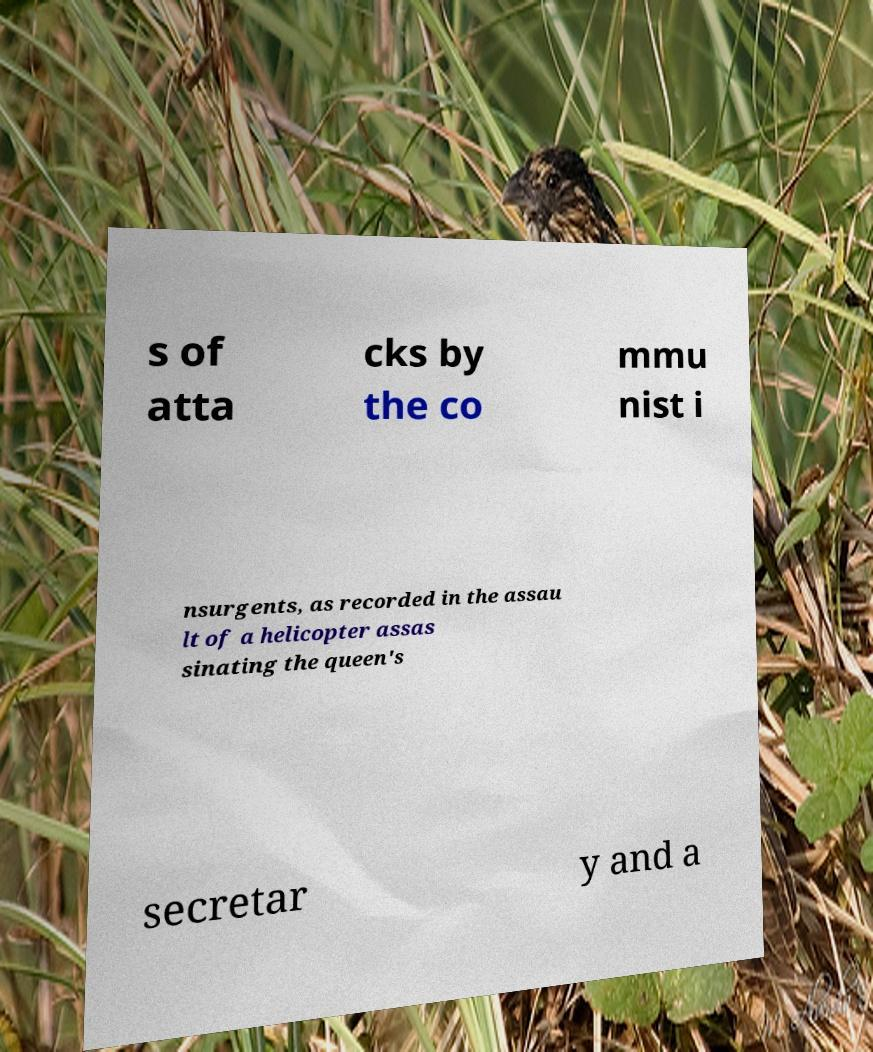There's text embedded in this image that I need extracted. Can you transcribe it verbatim? s of atta cks by the co mmu nist i nsurgents, as recorded in the assau lt of a helicopter assas sinating the queen's secretar y and a 